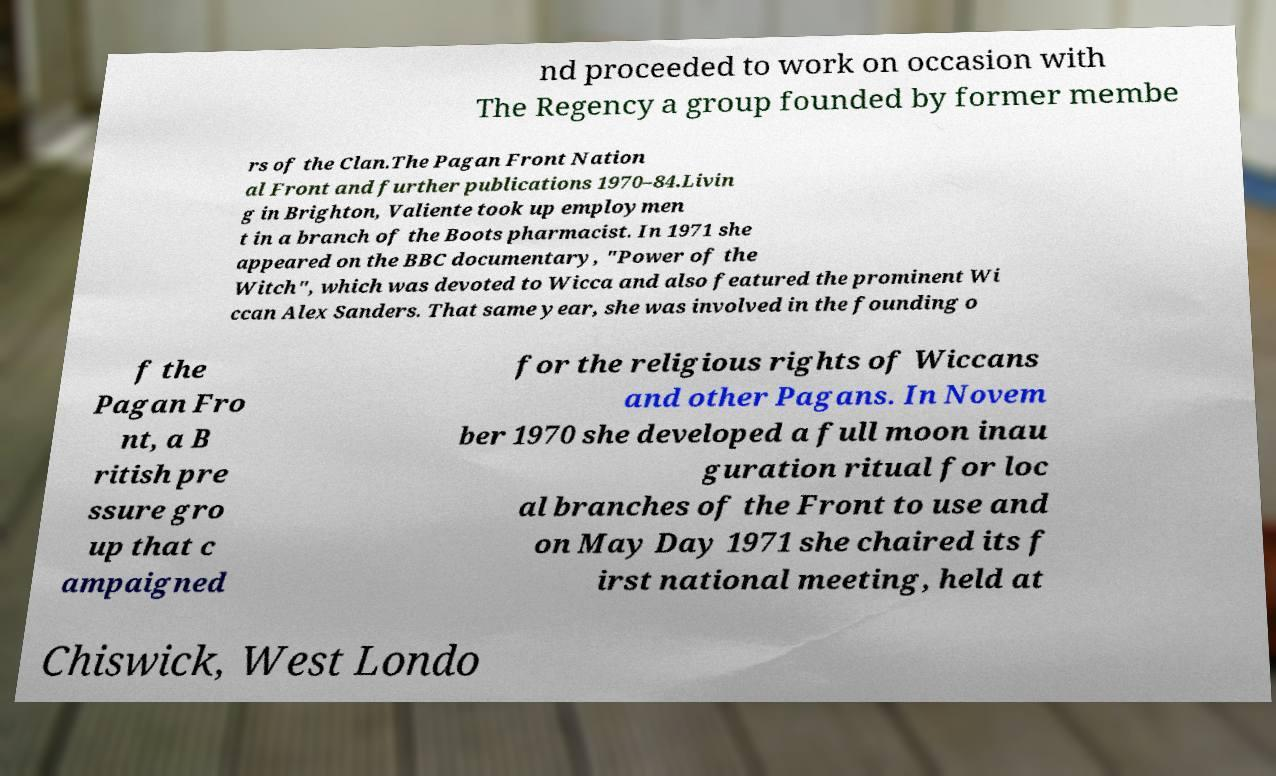For documentation purposes, I need the text within this image transcribed. Could you provide that? nd proceeded to work on occasion with The Regency a group founded by former membe rs of the Clan.The Pagan Front Nation al Front and further publications 1970–84.Livin g in Brighton, Valiente took up employmen t in a branch of the Boots pharmacist. In 1971 she appeared on the BBC documentary, "Power of the Witch", which was devoted to Wicca and also featured the prominent Wi ccan Alex Sanders. That same year, she was involved in the founding o f the Pagan Fro nt, a B ritish pre ssure gro up that c ampaigned for the religious rights of Wiccans and other Pagans. In Novem ber 1970 she developed a full moon inau guration ritual for loc al branches of the Front to use and on May Day 1971 she chaired its f irst national meeting, held at Chiswick, West Londo 